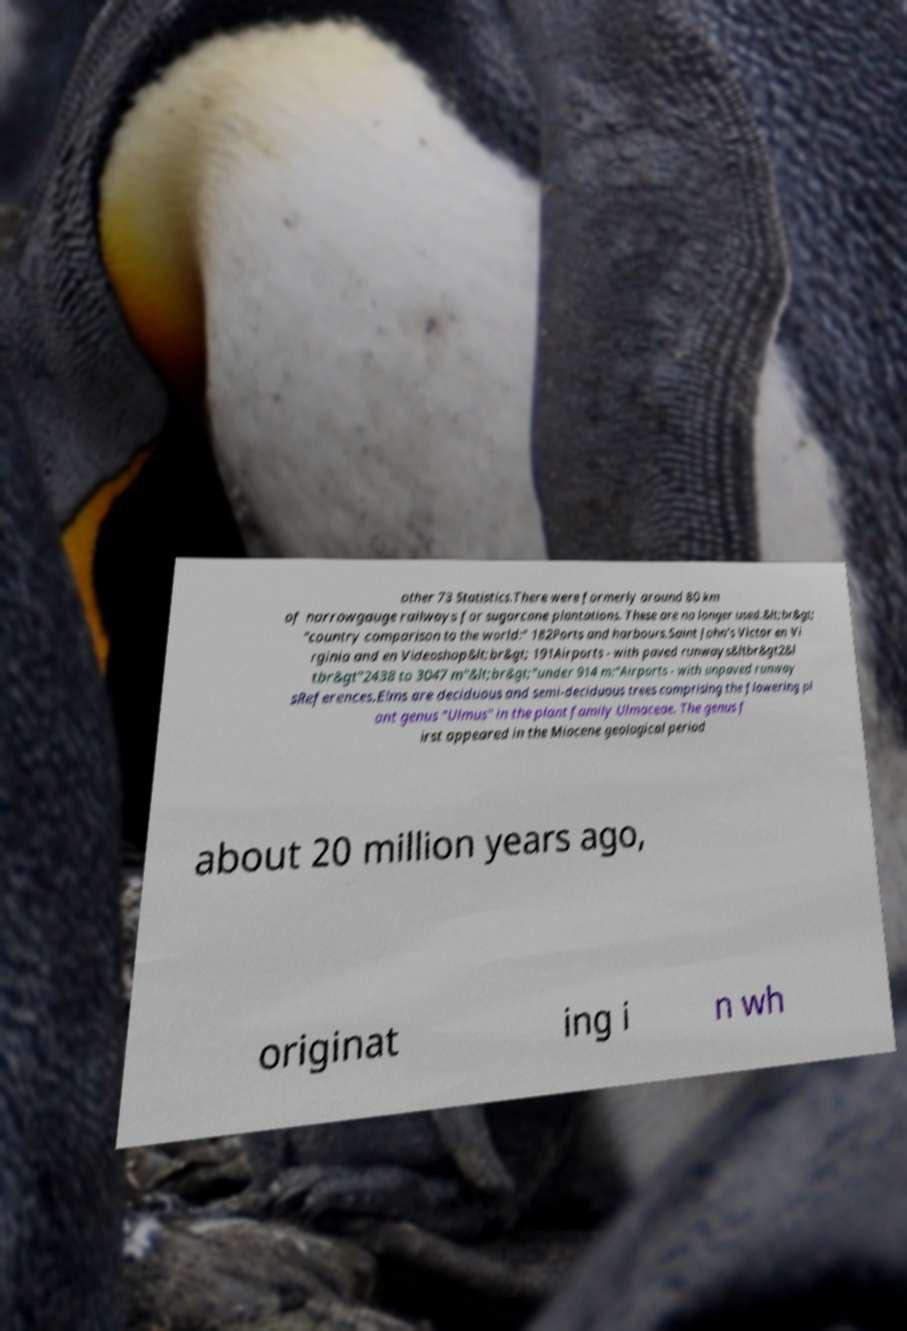What messages or text are displayed in this image? I need them in a readable, typed format. other 73 Statistics.There were formerly around 80 km of narrowgauge railways for sugarcane plantations. These are no longer used.&lt;br&gt; "country comparison to the world:" 182Ports and harbours.Saint John's Victor en Vi rginia and en Videoshop&lt;br&gt; 191Airports - with paved runways&ltbr&gt2&l tbr&gt"2438 to 3047 m"&lt;br&gt;"under 914 m:"Airports - with unpaved runway sReferences.Elms are deciduous and semi-deciduous trees comprising the flowering pl ant genus "Ulmus" in the plant family Ulmaceae. The genus f irst appeared in the Miocene geological period about 20 million years ago, originat ing i n wh 